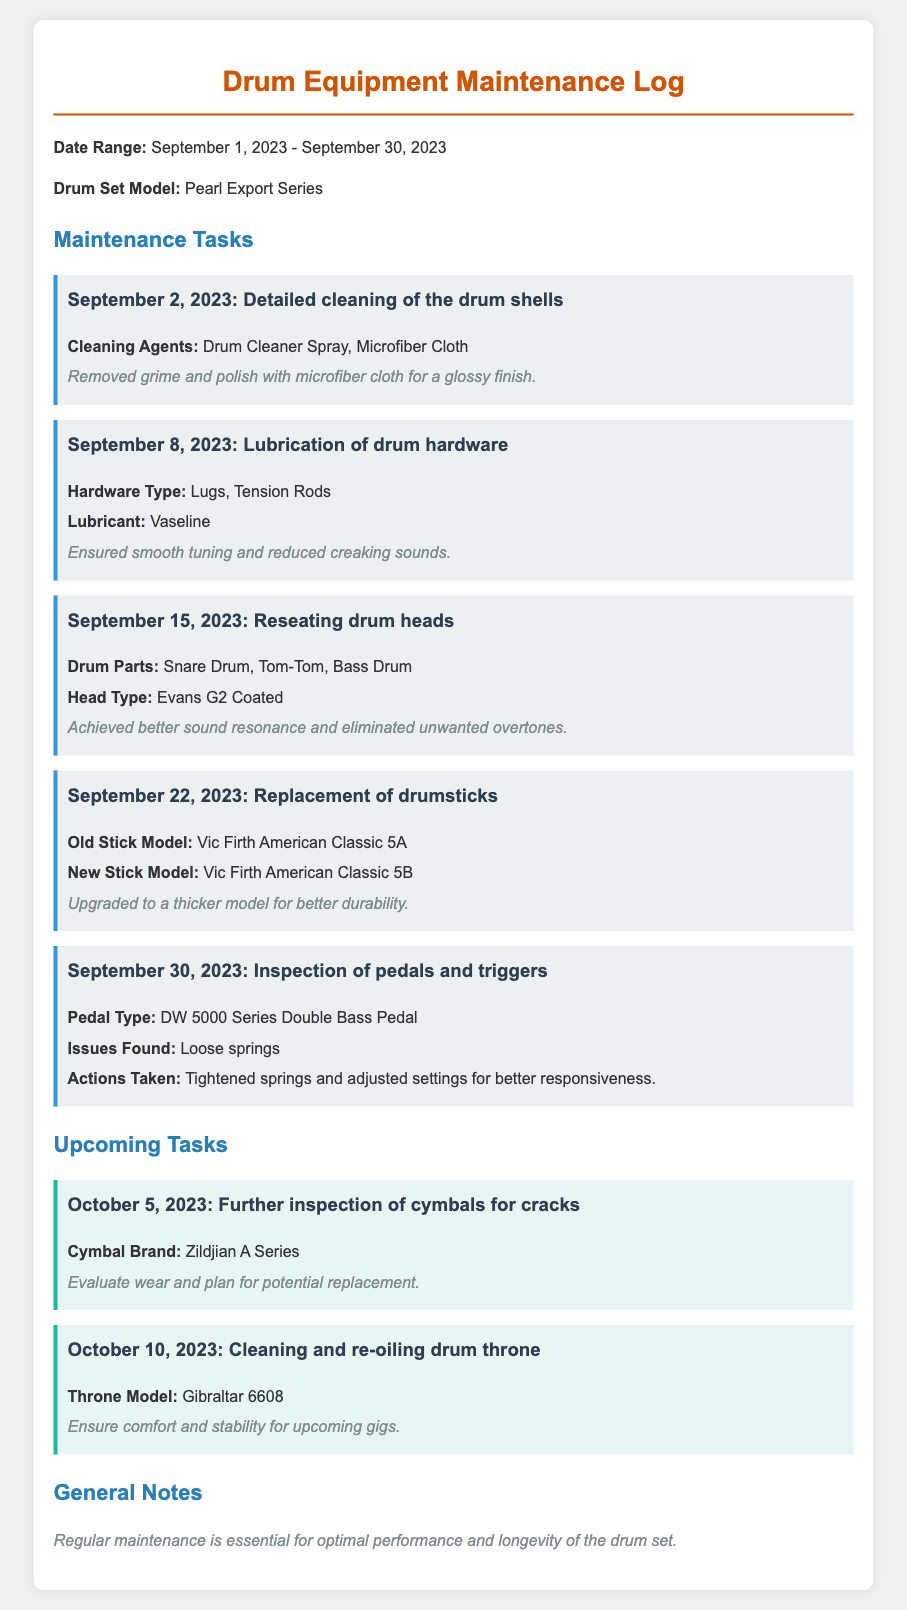What is the date range covered by the maintenance log? The date range is stated at the top of the document, showing the beginning and end dates for the maintenance log activities.
Answer: September 1, 2023 - September 30, 2023 What cleaning agent was used on September 2, 2023? The cleaning agents used for detailed cleaning on this date are specified in the task details for that date.
Answer: Drum Cleaner Spray, Microfiber Cloth Which drum heads were reseated on September 15, 2023? The task description provides information on what parts of the drum set had their heads reseated on this date.
Answer: Snare Drum, Tom-Tom, Bass Drum What was upgraded during the replacement of drumsticks? The notes indicate the reason behind the replacement of drumsticks and what was upgraded.
Answer: Thicker model for better durability What type of pedal was inspected on September 30, 2023? The type of pedal being inspected is mentioned in the task description for this date, providing specific information on the component.
Answer: DW 5000 Series Double Bass Pedal What is the upcoming task scheduled for October 5, 2023? This upcoming task is detailed under the Upcoming Tasks section, specifying what will be done on that date.
Answer: Further inspection of cymbals for cracks How many maintenance tasks are listed for September? The total number of tasks is calculated based on the tasks provided in the maintenance section of the document.
Answer: Five Which brand of cymbals will be evaluated for wear? The brand of cymbals mentioned for the upcoming inspection contains specific information found in the upcoming task details.
Answer: Zildjian A Series 